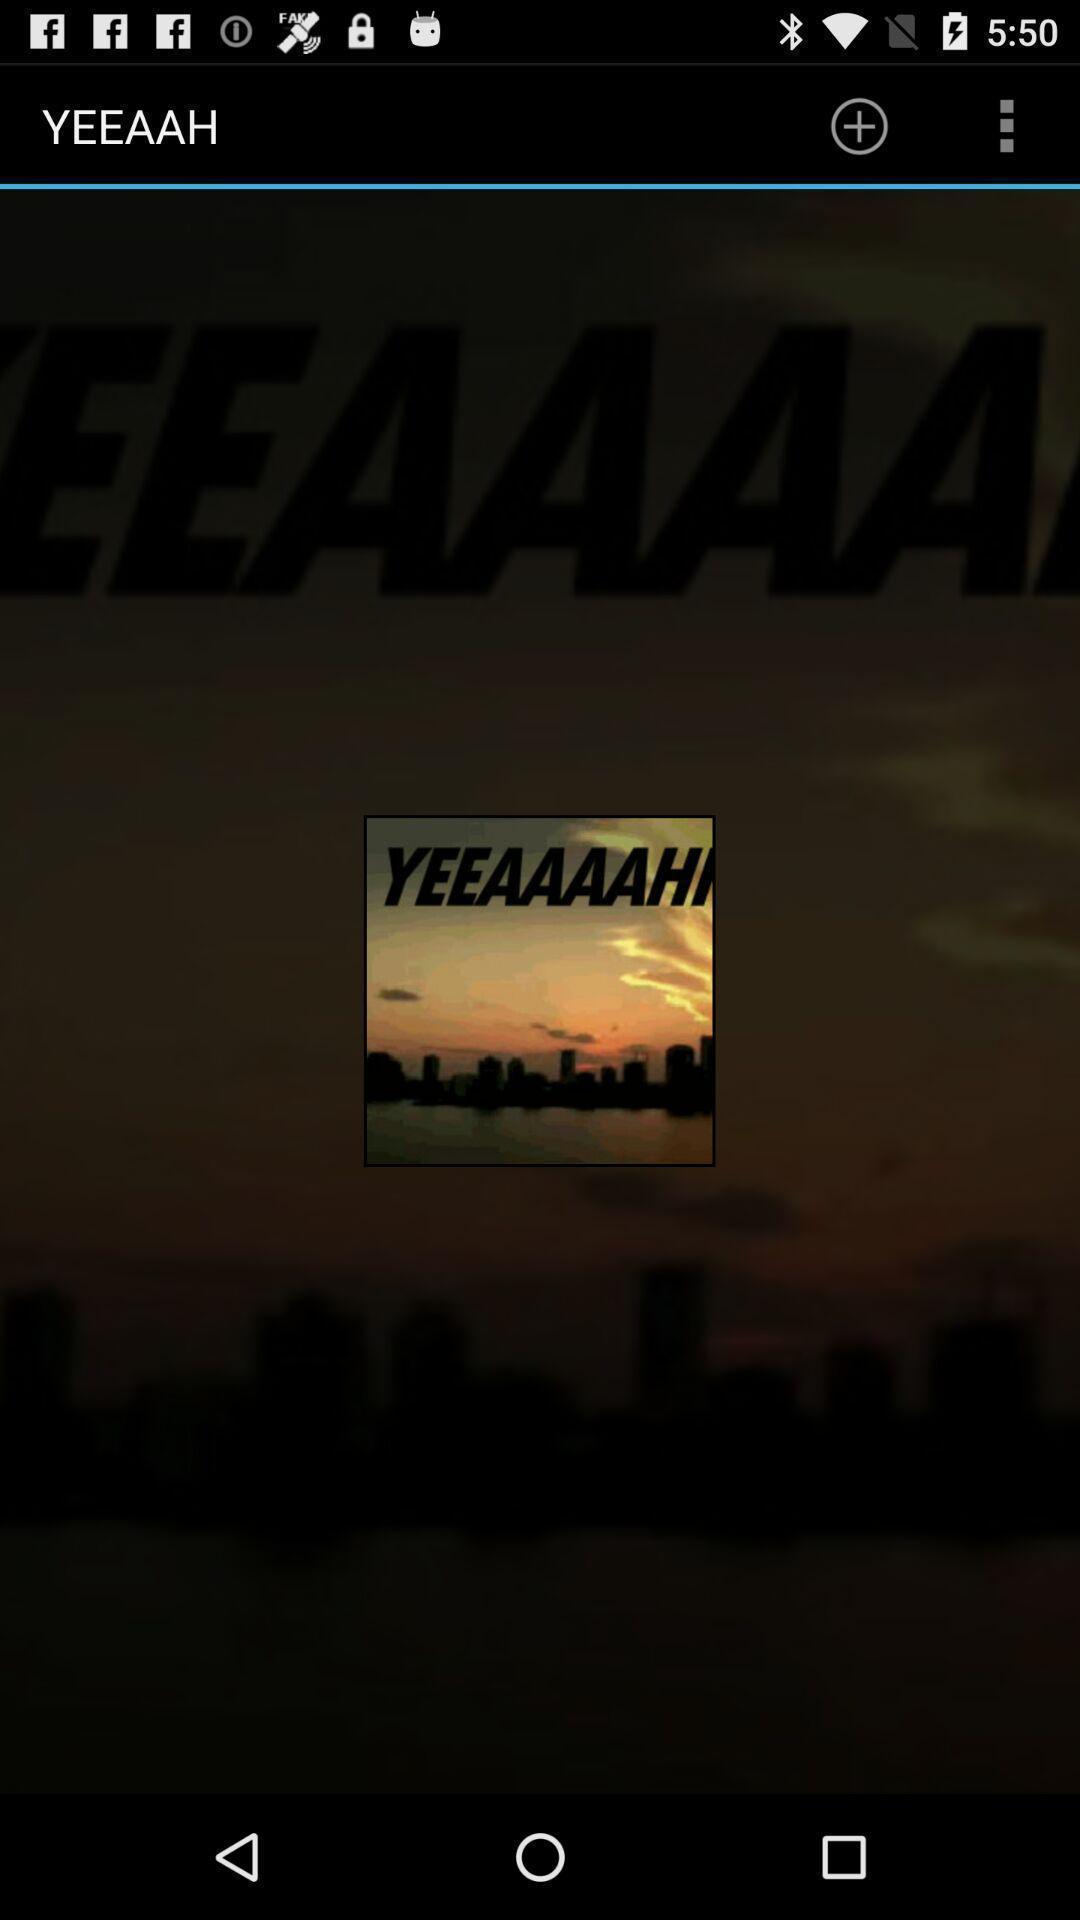Explain what's happening in this screen capture. Pop up image displayed. 